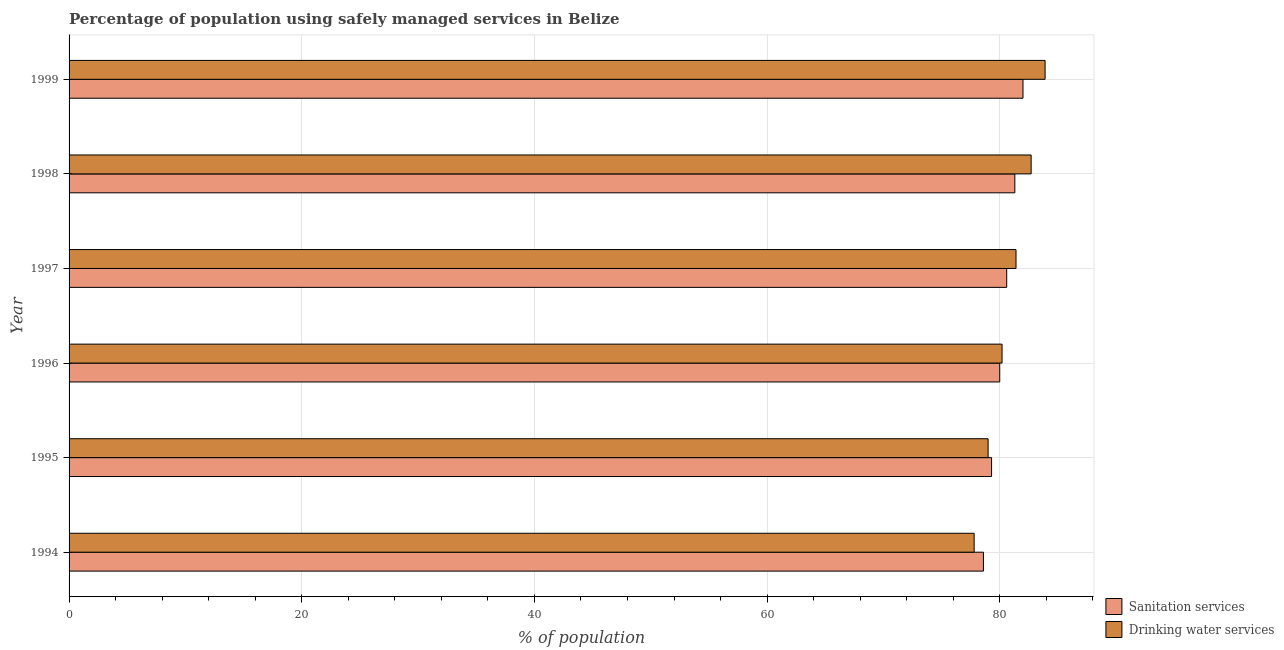Are the number of bars per tick equal to the number of legend labels?
Your response must be concise. Yes. Are the number of bars on each tick of the Y-axis equal?
Your response must be concise. Yes. How many bars are there on the 6th tick from the top?
Provide a succinct answer. 2. What is the percentage of population who used sanitation services in 1994?
Your response must be concise. 78.6. Across all years, what is the maximum percentage of population who used drinking water services?
Provide a succinct answer. 83.9. Across all years, what is the minimum percentage of population who used drinking water services?
Offer a terse response. 77.8. In which year was the percentage of population who used sanitation services minimum?
Your response must be concise. 1994. What is the total percentage of population who used sanitation services in the graph?
Offer a very short reply. 481.8. What is the difference between the percentage of population who used drinking water services in 1998 and the percentage of population who used sanitation services in 1995?
Offer a terse response. 3.4. What is the average percentage of population who used drinking water services per year?
Offer a very short reply. 80.83. In the year 1994, what is the difference between the percentage of population who used sanitation services and percentage of population who used drinking water services?
Make the answer very short. 0.8. What is the ratio of the percentage of population who used sanitation services in 1995 to that in 1999?
Give a very brief answer. 0.97. Is the difference between the percentage of population who used drinking water services in 1996 and 1999 greater than the difference between the percentage of population who used sanitation services in 1996 and 1999?
Offer a very short reply. No. In how many years, is the percentage of population who used drinking water services greater than the average percentage of population who used drinking water services taken over all years?
Make the answer very short. 3. Is the sum of the percentage of population who used drinking water services in 1994 and 1998 greater than the maximum percentage of population who used sanitation services across all years?
Ensure brevity in your answer.  Yes. What does the 1st bar from the top in 1996 represents?
Ensure brevity in your answer.  Drinking water services. What does the 2nd bar from the bottom in 1999 represents?
Your response must be concise. Drinking water services. How many bars are there?
Your answer should be compact. 12. How many years are there in the graph?
Your answer should be compact. 6. Does the graph contain any zero values?
Give a very brief answer. No. Does the graph contain grids?
Provide a succinct answer. Yes. How are the legend labels stacked?
Your answer should be very brief. Vertical. What is the title of the graph?
Your answer should be compact. Percentage of population using safely managed services in Belize. Does "Under-5(female)" appear as one of the legend labels in the graph?
Your response must be concise. No. What is the label or title of the X-axis?
Your answer should be very brief. % of population. What is the label or title of the Y-axis?
Your answer should be very brief. Year. What is the % of population of Sanitation services in 1994?
Keep it short and to the point. 78.6. What is the % of population in Drinking water services in 1994?
Offer a very short reply. 77.8. What is the % of population of Sanitation services in 1995?
Offer a terse response. 79.3. What is the % of population in Drinking water services in 1995?
Your response must be concise. 79. What is the % of population of Sanitation services in 1996?
Your response must be concise. 80. What is the % of population in Drinking water services in 1996?
Ensure brevity in your answer.  80.2. What is the % of population in Sanitation services in 1997?
Give a very brief answer. 80.6. What is the % of population in Drinking water services in 1997?
Keep it short and to the point. 81.4. What is the % of population of Sanitation services in 1998?
Keep it short and to the point. 81.3. What is the % of population of Drinking water services in 1998?
Offer a terse response. 82.7. What is the % of population in Sanitation services in 1999?
Your response must be concise. 82. What is the % of population of Drinking water services in 1999?
Make the answer very short. 83.9. Across all years, what is the maximum % of population in Drinking water services?
Your answer should be very brief. 83.9. Across all years, what is the minimum % of population in Sanitation services?
Provide a short and direct response. 78.6. Across all years, what is the minimum % of population in Drinking water services?
Provide a short and direct response. 77.8. What is the total % of population of Sanitation services in the graph?
Provide a succinct answer. 481.8. What is the total % of population of Drinking water services in the graph?
Provide a short and direct response. 485. What is the difference between the % of population of Sanitation services in 1994 and that in 1995?
Your response must be concise. -0.7. What is the difference between the % of population in Drinking water services in 1994 and that in 1995?
Offer a terse response. -1.2. What is the difference between the % of population in Sanitation services in 1994 and that in 1996?
Give a very brief answer. -1.4. What is the difference between the % of population in Sanitation services in 1994 and that in 1997?
Your answer should be very brief. -2. What is the difference between the % of population in Drinking water services in 1994 and that in 1999?
Provide a short and direct response. -6.1. What is the difference between the % of population of Sanitation services in 1995 and that in 1996?
Provide a succinct answer. -0.7. What is the difference between the % of population of Drinking water services in 1995 and that in 1996?
Offer a very short reply. -1.2. What is the difference between the % of population of Sanitation services in 1995 and that in 1997?
Ensure brevity in your answer.  -1.3. What is the difference between the % of population of Drinking water services in 1995 and that in 1997?
Your answer should be compact. -2.4. What is the difference between the % of population in Sanitation services in 1995 and that in 1998?
Provide a succinct answer. -2. What is the difference between the % of population of Drinking water services in 1995 and that in 1998?
Your answer should be compact. -3.7. What is the difference between the % of population in Drinking water services in 1996 and that in 1998?
Give a very brief answer. -2.5. What is the difference between the % of population in Sanitation services in 1996 and that in 1999?
Keep it short and to the point. -2. What is the difference between the % of population of Drinking water services in 1996 and that in 1999?
Your answer should be compact. -3.7. What is the difference between the % of population in Sanitation services in 1997 and that in 1999?
Provide a succinct answer. -1.4. What is the difference between the % of population in Sanitation services in 1994 and the % of population in Drinking water services in 1997?
Keep it short and to the point. -2.8. What is the difference between the % of population in Sanitation services in 1995 and the % of population in Drinking water services in 1997?
Offer a very short reply. -2.1. What is the difference between the % of population in Sanitation services in 1995 and the % of population in Drinking water services in 1998?
Make the answer very short. -3.4. What is the difference between the % of population of Sanitation services in 1997 and the % of population of Drinking water services in 1998?
Keep it short and to the point. -2.1. What is the average % of population in Sanitation services per year?
Your answer should be compact. 80.3. What is the average % of population in Drinking water services per year?
Ensure brevity in your answer.  80.83. In the year 1994, what is the difference between the % of population of Sanitation services and % of population of Drinking water services?
Your response must be concise. 0.8. What is the ratio of the % of population of Sanitation services in 1994 to that in 1996?
Provide a short and direct response. 0.98. What is the ratio of the % of population in Drinking water services in 1994 to that in 1996?
Ensure brevity in your answer.  0.97. What is the ratio of the % of population in Sanitation services in 1994 to that in 1997?
Make the answer very short. 0.98. What is the ratio of the % of population in Drinking water services in 1994 to that in 1997?
Offer a very short reply. 0.96. What is the ratio of the % of population of Sanitation services in 1994 to that in 1998?
Give a very brief answer. 0.97. What is the ratio of the % of population in Drinking water services in 1994 to that in 1998?
Offer a very short reply. 0.94. What is the ratio of the % of population of Sanitation services in 1994 to that in 1999?
Make the answer very short. 0.96. What is the ratio of the % of population of Drinking water services in 1994 to that in 1999?
Keep it short and to the point. 0.93. What is the ratio of the % of population in Drinking water services in 1995 to that in 1996?
Provide a succinct answer. 0.98. What is the ratio of the % of population of Sanitation services in 1995 to that in 1997?
Offer a terse response. 0.98. What is the ratio of the % of population of Drinking water services in 1995 to that in 1997?
Ensure brevity in your answer.  0.97. What is the ratio of the % of population of Sanitation services in 1995 to that in 1998?
Offer a terse response. 0.98. What is the ratio of the % of population in Drinking water services in 1995 to that in 1998?
Provide a short and direct response. 0.96. What is the ratio of the % of population of Sanitation services in 1995 to that in 1999?
Your answer should be very brief. 0.97. What is the ratio of the % of population in Drinking water services in 1995 to that in 1999?
Offer a very short reply. 0.94. What is the ratio of the % of population of Sanitation services in 1996 to that in 1997?
Keep it short and to the point. 0.99. What is the ratio of the % of population in Sanitation services in 1996 to that in 1998?
Your answer should be compact. 0.98. What is the ratio of the % of population in Drinking water services in 1996 to that in 1998?
Your answer should be very brief. 0.97. What is the ratio of the % of population in Sanitation services in 1996 to that in 1999?
Your answer should be compact. 0.98. What is the ratio of the % of population in Drinking water services in 1996 to that in 1999?
Your answer should be compact. 0.96. What is the ratio of the % of population of Drinking water services in 1997 to that in 1998?
Your answer should be compact. 0.98. What is the ratio of the % of population in Sanitation services in 1997 to that in 1999?
Provide a short and direct response. 0.98. What is the ratio of the % of population of Drinking water services in 1997 to that in 1999?
Your response must be concise. 0.97. What is the ratio of the % of population in Sanitation services in 1998 to that in 1999?
Give a very brief answer. 0.99. What is the ratio of the % of population in Drinking water services in 1998 to that in 1999?
Offer a very short reply. 0.99. What is the difference between the highest and the second highest % of population of Sanitation services?
Give a very brief answer. 0.7. What is the difference between the highest and the lowest % of population in Sanitation services?
Keep it short and to the point. 3.4. What is the difference between the highest and the lowest % of population in Drinking water services?
Make the answer very short. 6.1. 